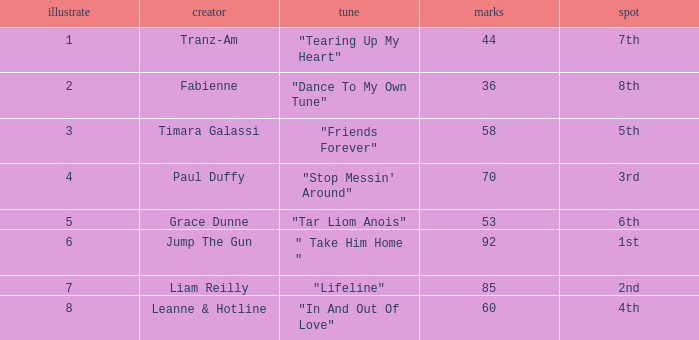What's the highest draw with over 60 points for paul duffy? 4.0. 